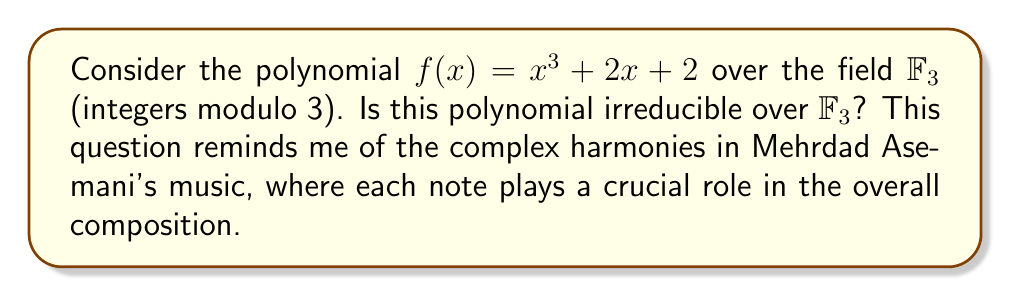Show me your answer to this math problem. To determine if $f(x) = x^3 + 2x + 2$ is irreducible over $\mathbb{F}_3$, we can follow these steps:

1) First, note that $f(x)$ is a cubic polynomial, so it could only be reducible if it has a linear factor $(x - a)$ where $a \in \mathbb{F}_3 = \{0, 1, 2\}$.

2) If $(x - a)$ is a factor, then $f(a) = 0$ in $\mathbb{F}_3$. So, we need to check if $f(0)$, $f(1)$, or $f(2)$ is equal to 0 in $\mathbb{F}_3$.

3) Let's evaluate $f(x)$ for each element of $\mathbb{F}_3$:

   $f(0) = 0^3 + 2(0) + 2 \equiv 2 \pmod{3}$
   
   $f(1) = 1^3 + 2(1) + 2 \equiv 1 + 2 + 2 \equiv 2 \pmod{3}$
   
   $f(2) = 2^3 + 2(2) + 2 \equiv 2 + 1 + 2 \equiv 2 \pmod{3}$

4) We see that $f(x)$ doesn't evaluate to 0 for any element in $\mathbb{F}_3$. This means $f(x)$ has no linear factors in $\mathbb{F}_3$.

5) Since $f(x)$ is a cubic polynomial with no linear factors in $\mathbb{F}_3$, it must be irreducible over $\mathbb{F}_3$.

This process of checking each possibility reminds me of how Mehrdad Asemani carefully selects each note in his compositions, ensuring that every element contributes to the overall irreducibility of his musical pieces.
Answer: Yes, the polynomial $f(x) = x^3 + 2x + 2$ is irreducible over $\mathbb{F}_3$. 